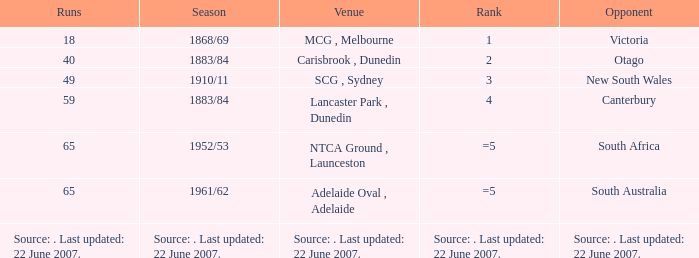Which Runs has a Opponent of south australia? 65.0. Parse the table in full. {'header': ['Runs', 'Season', 'Venue', 'Rank', 'Opponent'], 'rows': [['18', '1868/69', 'MCG , Melbourne', '1', 'Victoria'], ['40', '1883/84', 'Carisbrook , Dunedin', '2', 'Otago'], ['49', '1910/11', 'SCG , Sydney', '3', 'New South Wales'], ['59', '1883/84', 'Lancaster Park , Dunedin', '4', 'Canterbury'], ['65', '1952/53', 'NTCA Ground , Launceston', '=5', 'South Africa'], ['65', '1961/62', 'Adelaide Oval , Adelaide', '=5', 'South Australia'], ['Source: . Last updated: 22 June 2007.', 'Source: . Last updated: 22 June 2007.', 'Source: . Last updated: 22 June 2007.', 'Source: . Last updated: 22 June 2007.', 'Source: . Last updated: 22 June 2007.']]} 